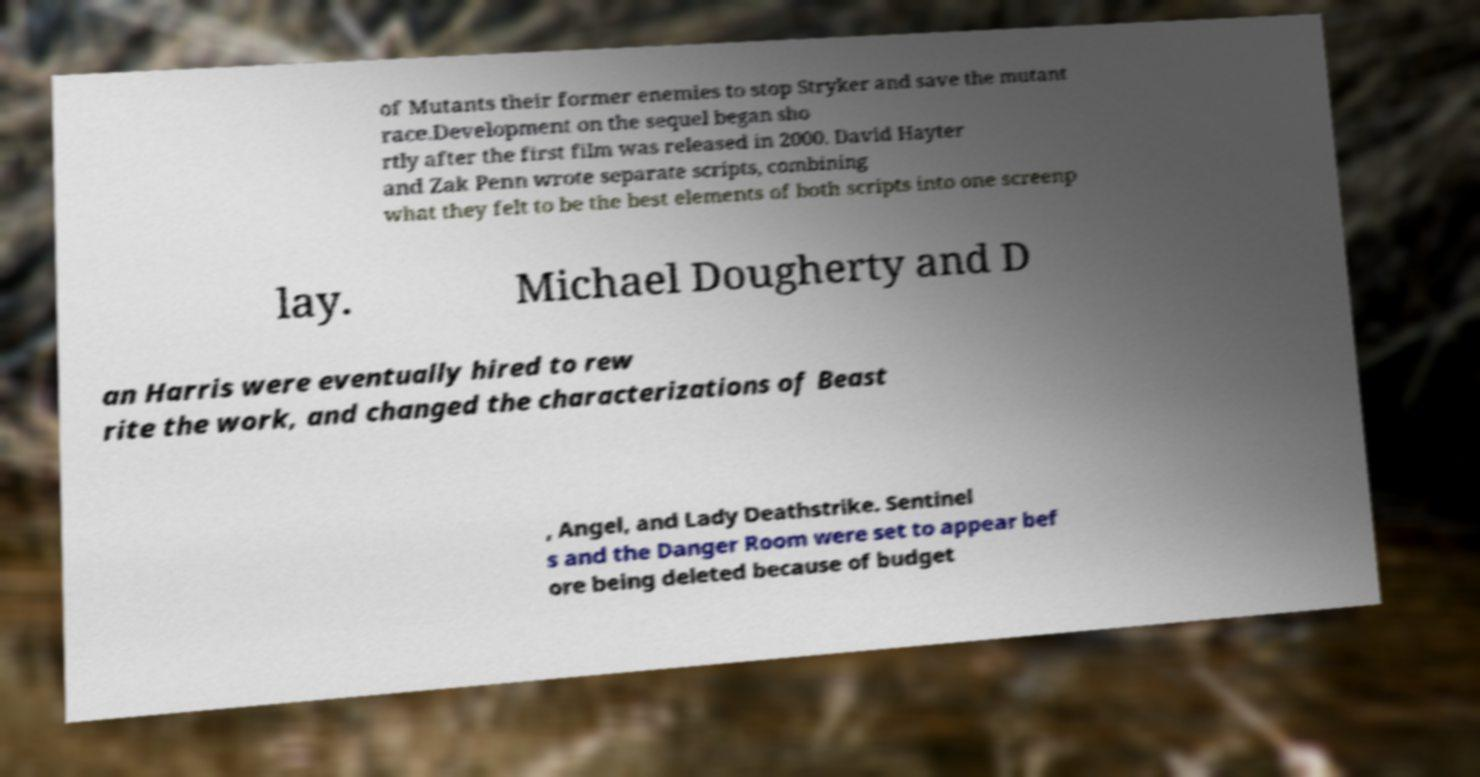I need the written content from this picture converted into text. Can you do that? of Mutants their former enemies to stop Stryker and save the mutant race.Development on the sequel began sho rtly after the first film was released in 2000. David Hayter and Zak Penn wrote separate scripts, combining what they felt to be the best elements of both scripts into one screenp lay. Michael Dougherty and D an Harris were eventually hired to rew rite the work, and changed the characterizations of Beast , Angel, and Lady Deathstrike. Sentinel s and the Danger Room were set to appear bef ore being deleted because of budget 